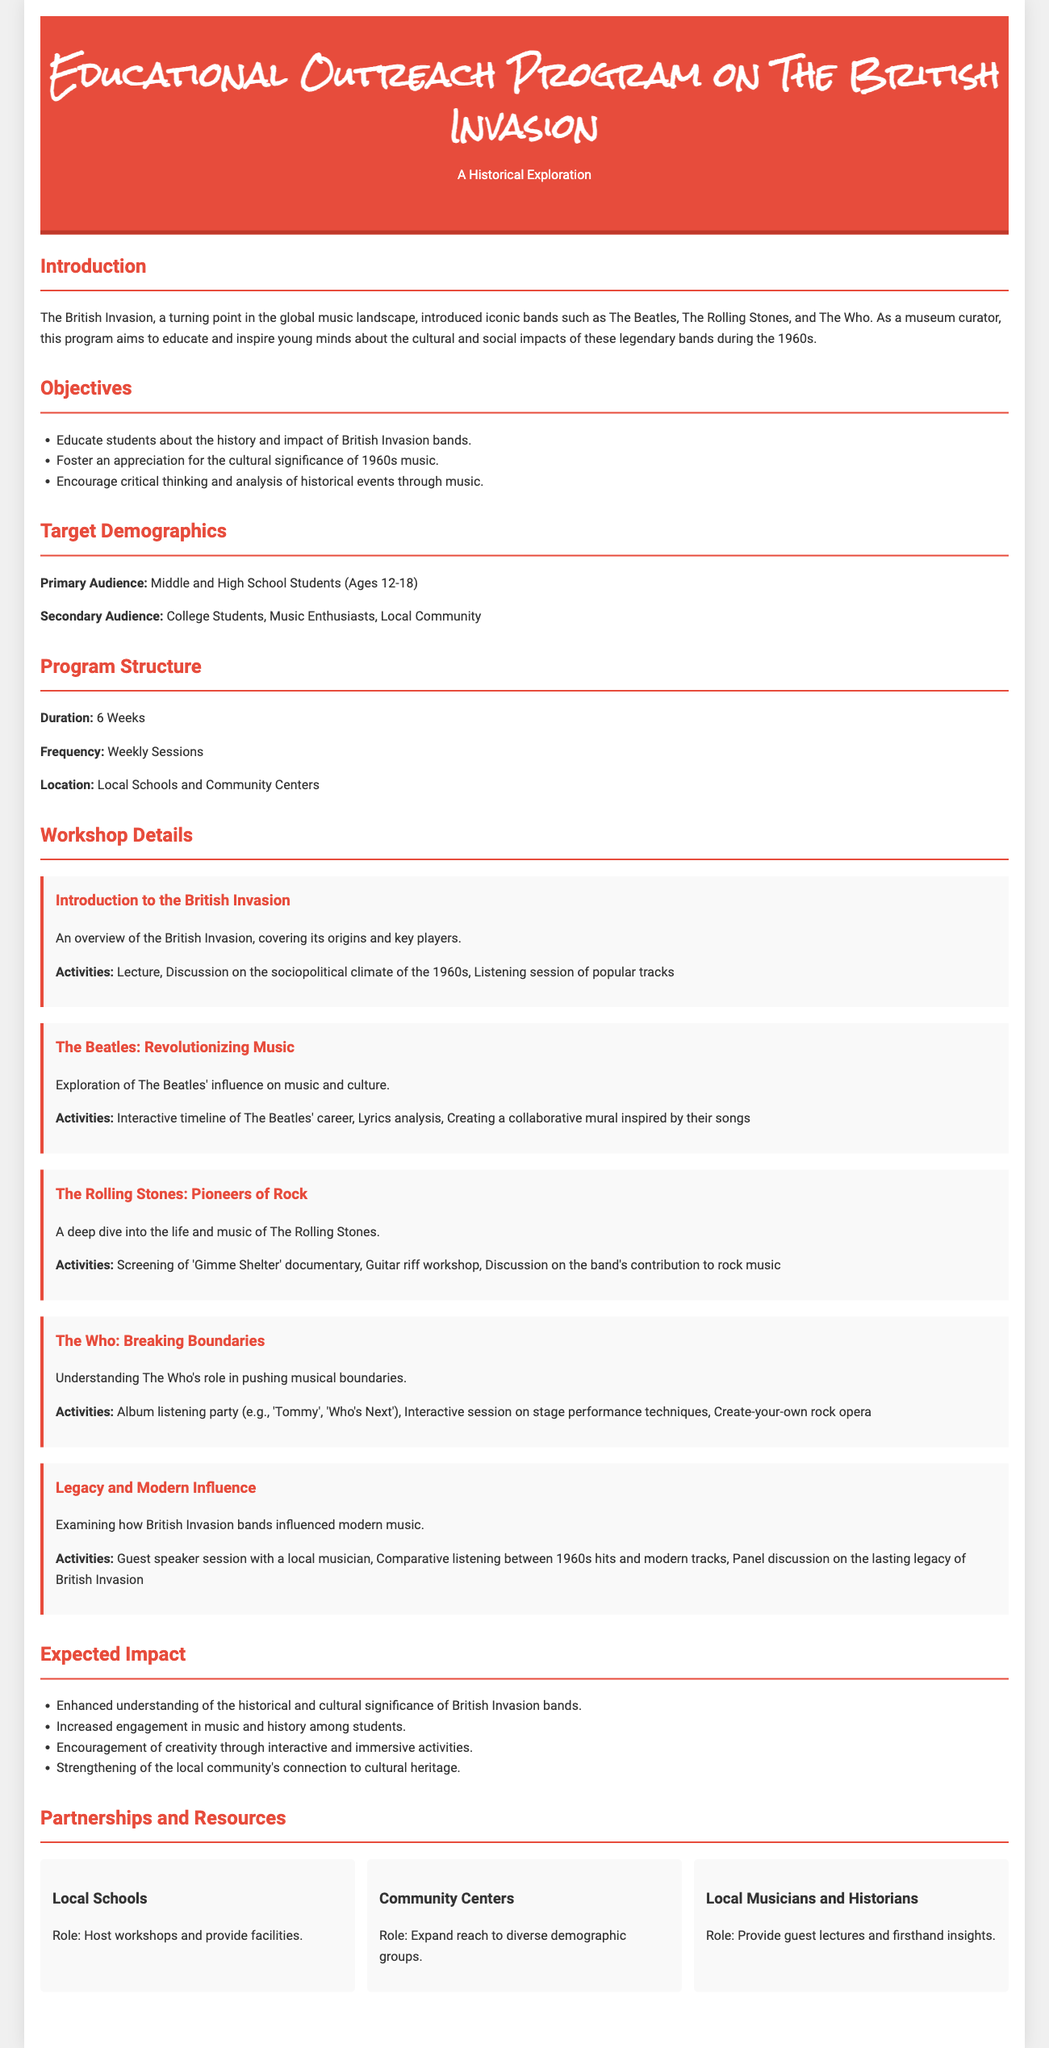What is the duration of the program? The duration of the program is specified as 6 weeks in the document.
Answer: 6 Weeks Who are the primary audience members targeted by the program? The primary audience is identified as Middle and High School Students (Ages 12-18) in the document.
Answer: Middle and High School Students (Ages 12-18) What workshop focuses on The Beatles? The workshop titled "The Beatles: Revolutionizing Music" addresses The Beatles in the program.
Answer: The Beatles: Revolutionizing Music What is one expected impact of the program? The document lists several expected impacts, one of which is enhanced understanding of the historical significance of British Invasion bands.
Answer: Enhanced understanding of the historical and cultural significance How often will the workshops be held? The document states that the workshops will be held weekly.
Answer: Weekly Sessions What type of organizations are mentioned as partners in the program? The program mentions Local Schools, Community Centers, and Local Musicians and Historians as partners.
Answer: Local Schools, Community Centers, Local Musicians and Historians What is the title of the proposal? The proposal's title is found in the header of the document.
Answer: Educational Outreach Program on The British Invasion What is one activity included in "The Who: Breaking Boundaries" workshop? The document lists an "Album listening party" as one of the activities for this workshop.
Answer: Album listening party What is the primary aim of the educational outreach program? The program primarily aims to educate and inspire students about British Invasion bands' cultural impacts.
Answer: Educate and inspire students about the cultural and social impacts 